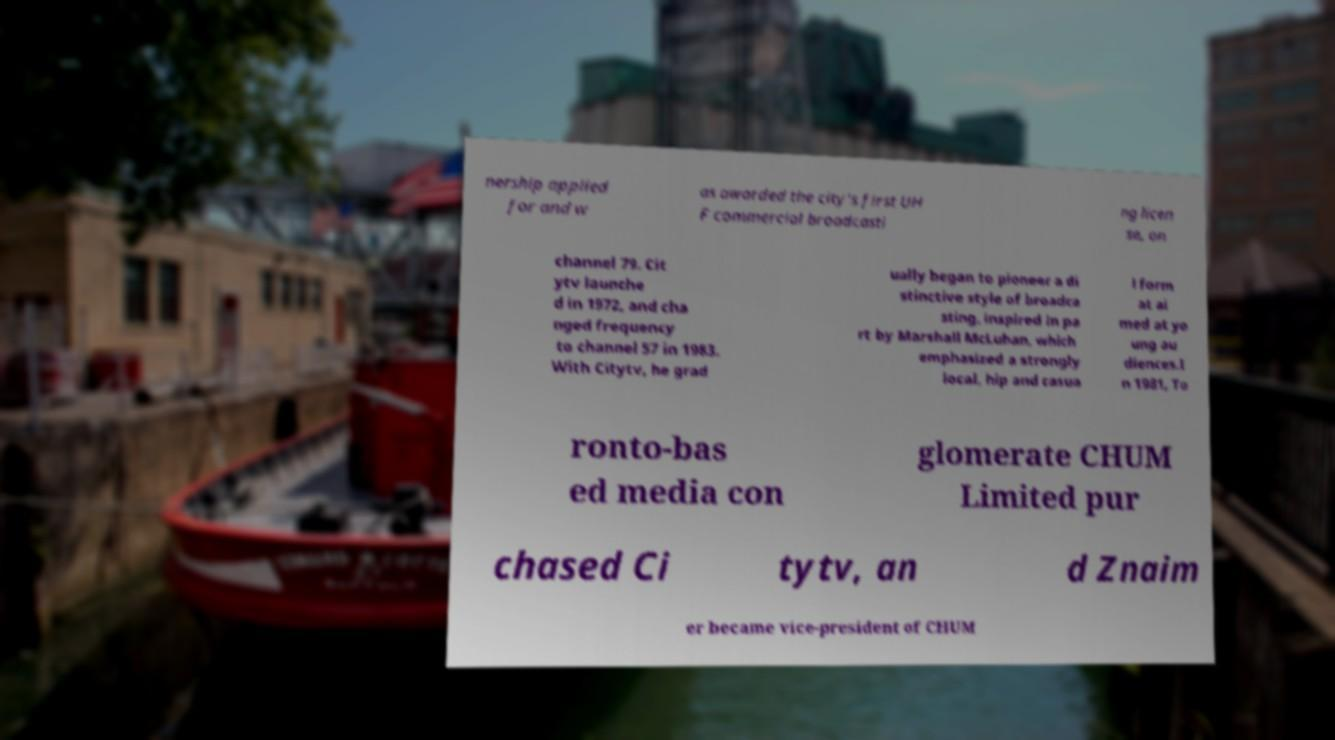Please identify and transcribe the text found in this image. nership applied for and w as awarded the city's first UH F commercial broadcasti ng licen se, on channel 79. Cit ytv launche d in 1972, and cha nged frequency to channel 57 in 1983. With Citytv, he grad ually began to pioneer a di stinctive style of broadca sting, inspired in pa rt by Marshall McLuhan, which emphasized a strongly local, hip and casua l form at ai med at yo ung au diences.I n 1981, To ronto-bas ed media con glomerate CHUM Limited pur chased Ci tytv, an d Znaim er became vice-president of CHUM 